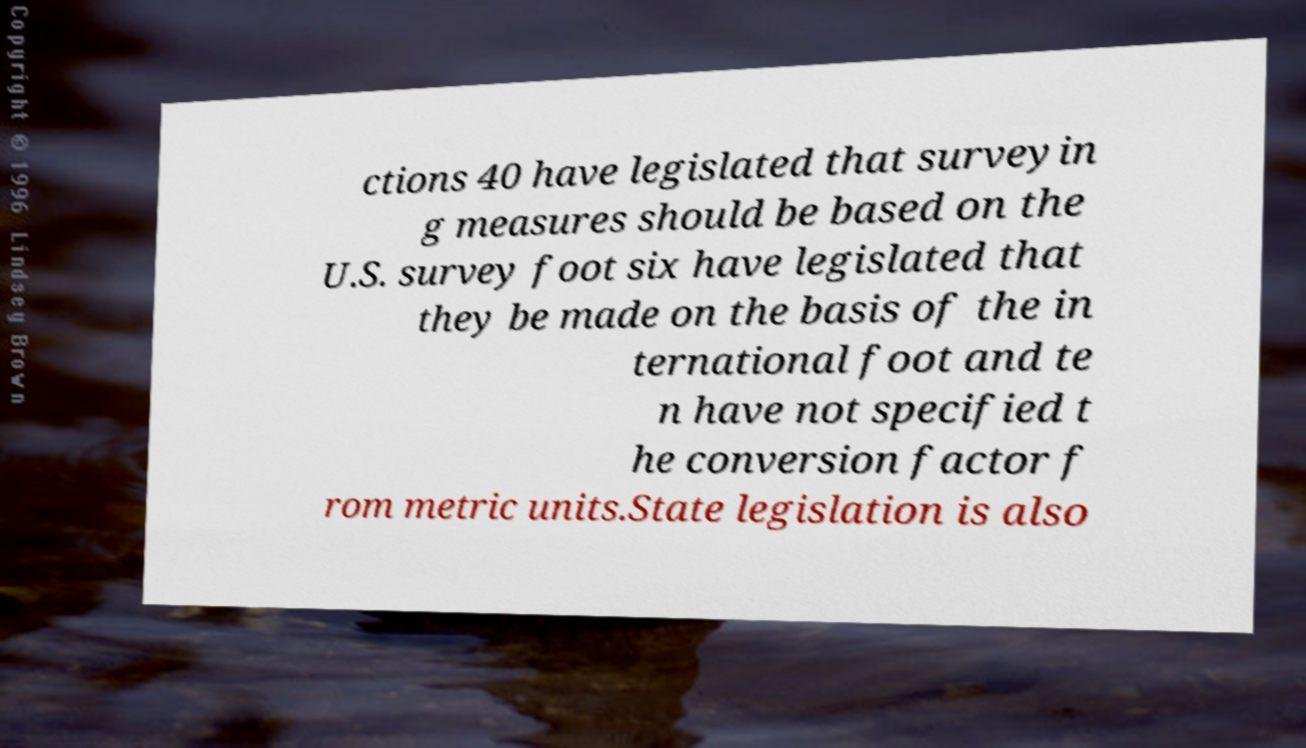Can you accurately transcribe the text from the provided image for me? ctions 40 have legislated that surveyin g measures should be based on the U.S. survey foot six have legislated that they be made on the basis of the in ternational foot and te n have not specified t he conversion factor f rom metric units.State legislation is also 